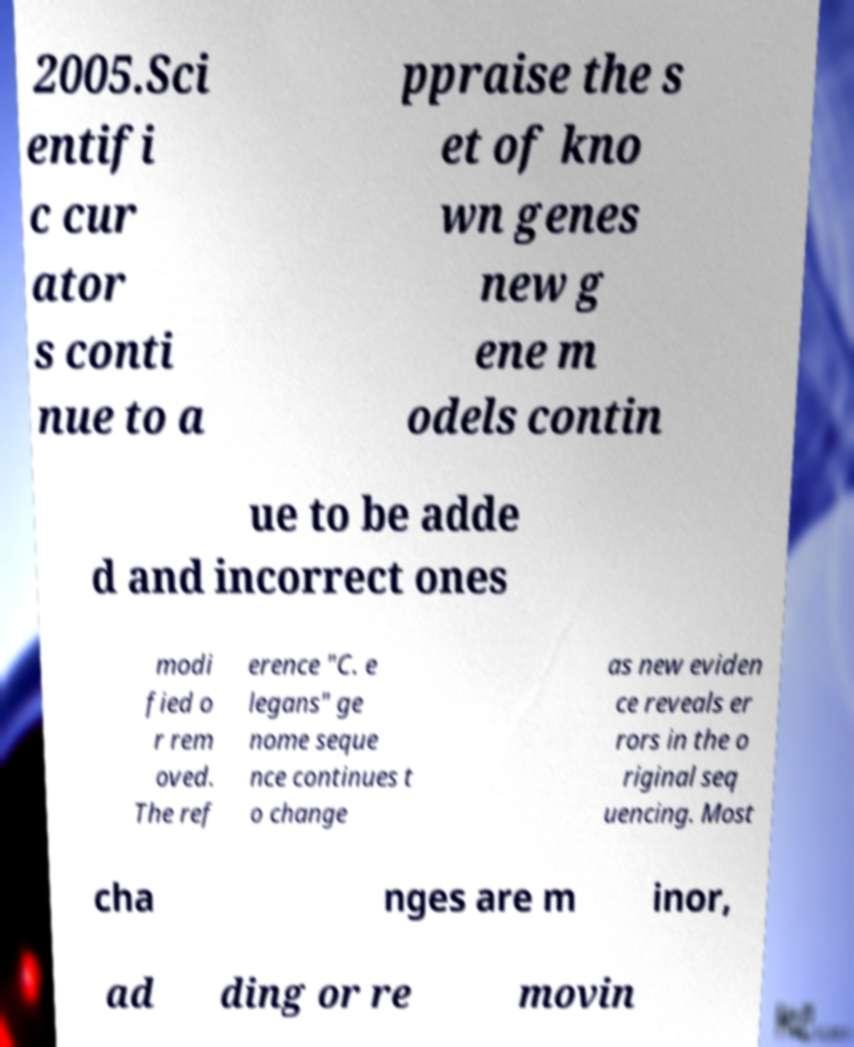Could you extract and type out the text from this image? 2005.Sci entifi c cur ator s conti nue to a ppraise the s et of kno wn genes new g ene m odels contin ue to be adde d and incorrect ones modi fied o r rem oved. The ref erence "C. e legans" ge nome seque nce continues t o change as new eviden ce reveals er rors in the o riginal seq uencing. Most cha nges are m inor, ad ding or re movin 